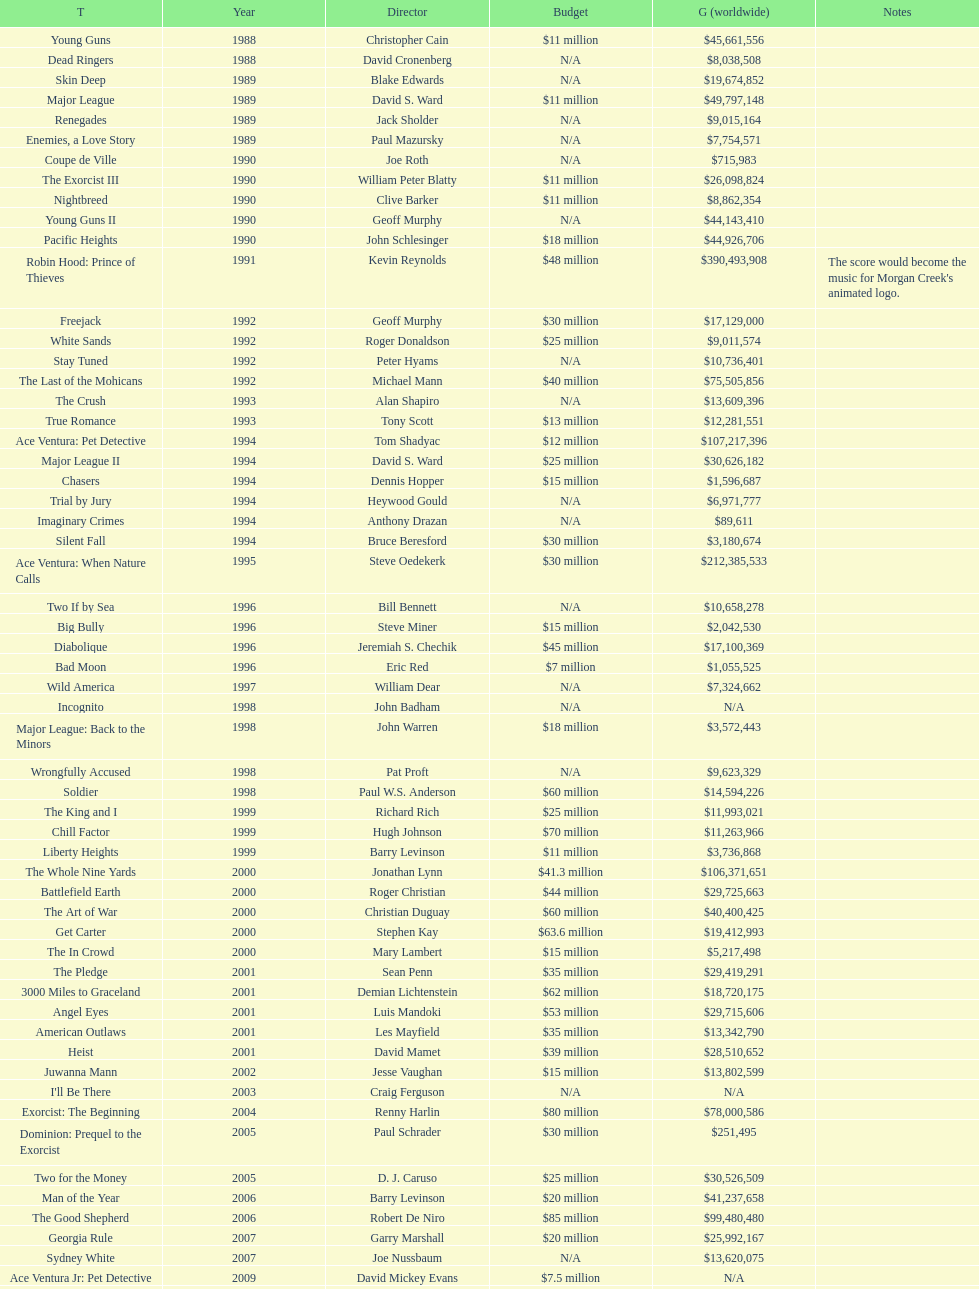After young guns, what was the next movie with the exact same budget? Major League. 